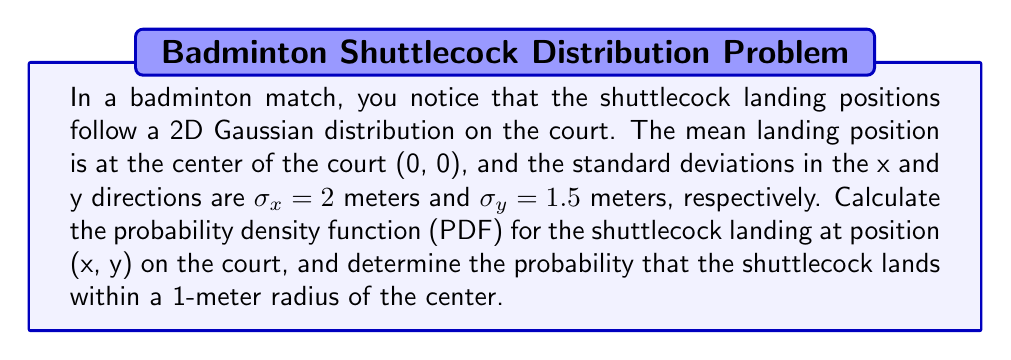Could you help me with this problem? 1. The 2D Gaussian distribution PDF is given by:

   $$f(x,y) = \frac{1}{2\pi\sigma_x\sigma_y} \exp\left(-\frac{1}{2}\left(\frac{x^2}{\sigma_x^2} + \frac{y^2}{\sigma_y^2}\right)\right)$$

2. Substituting the given values:
   $$f(x,y) = \frac{1}{2\pi(2)(1.5)} \exp\left(-\frac{1}{2}\left(\frac{x^2}{2^2} + \frac{y^2}{1.5^2}\right)\right)$$

3. Simplify:
   $$f(x,y) = \frac{1}{6\pi} \exp\left(-\frac{1}{2}\left(\frac{x^2}{4} + \frac{y^2}{2.25}\right)\right)$$

4. To find the probability within a 1-meter radius, we need to integrate the PDF over a circle:
   $$P(r \leq 1) = \int_{-1}^1 \int_{-\sqrt{1-x^2}}^{\sqrt{1-x^2}} f(x,y) dy dx$$

5. This integral is complex, but we can use the property that the integral of a 2D Gaussian over a circle is related to the cumulative distribution function of a chi-square distribution with 2 degrees of freedom:

   $$P(r \leq 1) = 1 - \exp\left(-\frac{1^2}{2(2^2+1.5^2)}\right)$$

6. Calculate:
   $$P(r \leq 1) = 1 - \exp\left(-\frac{1}{2(4+2.25)}\right) = 1 - \exp(-0.08) \approx 0.0770$$
Answer: PDF: $f(x,y) = \frac{1}{6\pi} \exp\left(-\frac{1}{2}\left(\frac{x^2}{4} + \frac{y^2}{2.25}\right)\right)$; Probability within 1-meter radius: 0.0770 or 7.70% 